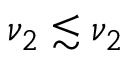<formula> <loc_0><loc_0><loc_500><loc_500>\nu _ { 2 } \lesssim \nu _ { 2 }</formula> 